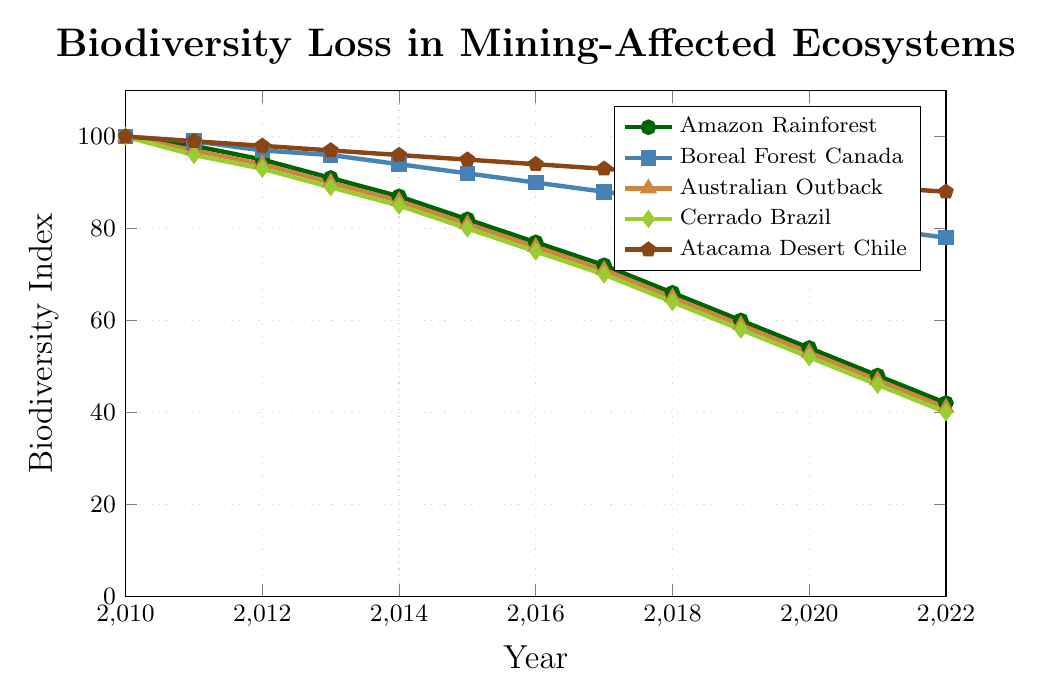What was the Biodiversity Index for the Boreal Forest Canada in 2015? Locate the point corresponding to Boreal Forest Canada on the graph for the year 2015, represented by a square. The y-axis value for this point is 92.
Answer: 92 Which ecosystem experienced the greatest absolute decline in Biodiversity Index from 2010 to 2022? To determine the greatest absolute decline, calculate the difference between the Biodiversity Index values in 2010 and 2022 for all ecosystems. 
Amazon Rainforest: 100 - 42 = 58
Boreal Forest Canada: 100 - 78 = 22
Australian Outback: 100 - 41 = 59
Cerrado Brazil: 100 - 40 = 60
Atacama Desert Chile: 100 - 88 = 12
The Cerrado Brazil experienced the greatest decline of 60.
Answer: Cerrado Brazil Compare the rate of decline in Biodiversity Index between the Amazon Rainforest and the Atacama Desert Chile from 2010 to 2022. Which had a steeper decline? Calculate the decline rate by dividing the difference by the number of years for both ecosystems.
Amazon Rainforest: (100 - 42) / (2022 - 2010) = 58 / 12 ≈ 4.83 per year
Atacama Desert Chile: (100 - 88) / (2022 - 2010) = 12 / 12 = 1 per year
The Amazon Rainforest had a steeper decline.
Answer: Amazon Rainforest By how much did the Biodiversity Index for the Australian Outback change from 2016 to 2018? Identify the Biodiversity Index values for the Australian Outback in 2016 and 2018. The change is calculated as: 
76 (2016) - 65 (2018) = 11.
Answer: 11 Identify the ecosystem that maintained the highest Biodiversity Index throughout the entire period. Compare the Biodiversity Index for each ecosystem across all years. The Atacama Desert Chile consistently has the highest values.
Answer: Atacama Desert Chile Calculate the average Biodiversity Index for the Cerrado Brazil between 2010 and 2022. Sum the Biodiversity Index values for the Cerrado Brazil from 2010 to 2022: 
100 + 96 + 93 + 89 + 85 + 80 + 75 + 70 + 64 + 58 + 52 + 46 + 40 = 948. 
Then divide by the number of years: 948 / 13 ≈ 72.92.
Answer: 72.92 Which year showed the most significant drop in Biodiversity Index for the Amazon Rainforest compared to the previous year? Determine the drop in the Amazon Rainforest biodiversity index year-over-year. The drops are: 
2010-2011: 100-98 = 2
2011-2012: 98-95 = 3
2012-2013: 95-91 = 4
2013-2014: 91-87 = 4
2014-2015: 87-82 = 5
2015-2016: 82-77 = 5
2016-2017: 77-72 = 5
2017-2018: 72-66 = 6
2018-2019: 66-60 = 6
2019-2020: 60-54 = 6
2020-2021: 54-48 = 6
2021-2022: 48-42 = 6
The years 2017-2018, 2018-2019, 2019-2020, 2020-2021, 2021-2022 showed the most significant drop of 6.
Answer: 2017-2022 Which two ecosystems are represented by colors that are both shades of green? By visually identifying the colors used in the chart, the Amazon Rainforest and Cerrado Brazil are both represented by shades of green.
Answer: Amazon Rainforest and Cerrado Brazil Calculate the cumulative Biodiversity Index loss for the Atacama Desert Chile from 2010 to 2022. Calculate the difference between the initial and final Biodiversity Index values: 100 (2010) - 88 (2022) = 12.
Answer: 12 